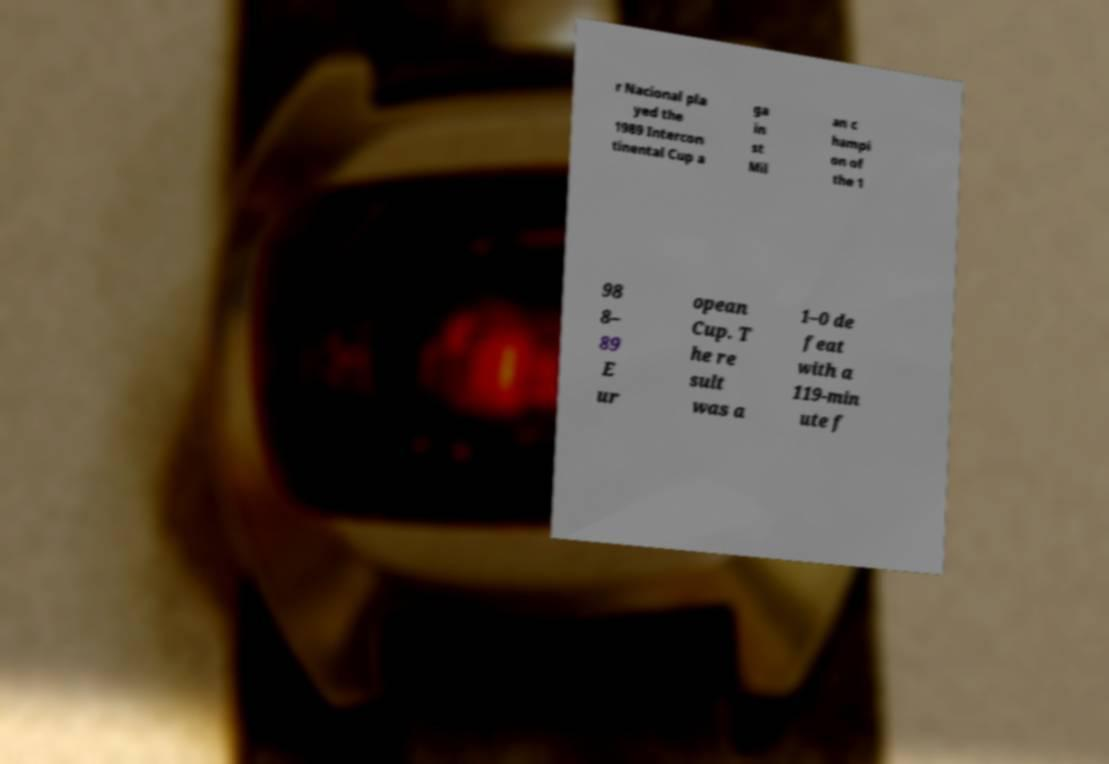There's text embedded in this image that I need extracted. Can you transcribe it verbatim? r Nacional pla yed the 1989 Intercon tinental Cup a ga in st Mil an c hampi on of the 1 98 8– 89 E ur opean Cup. T he re sult was a 1–0 de feat with a 119-min ute f 